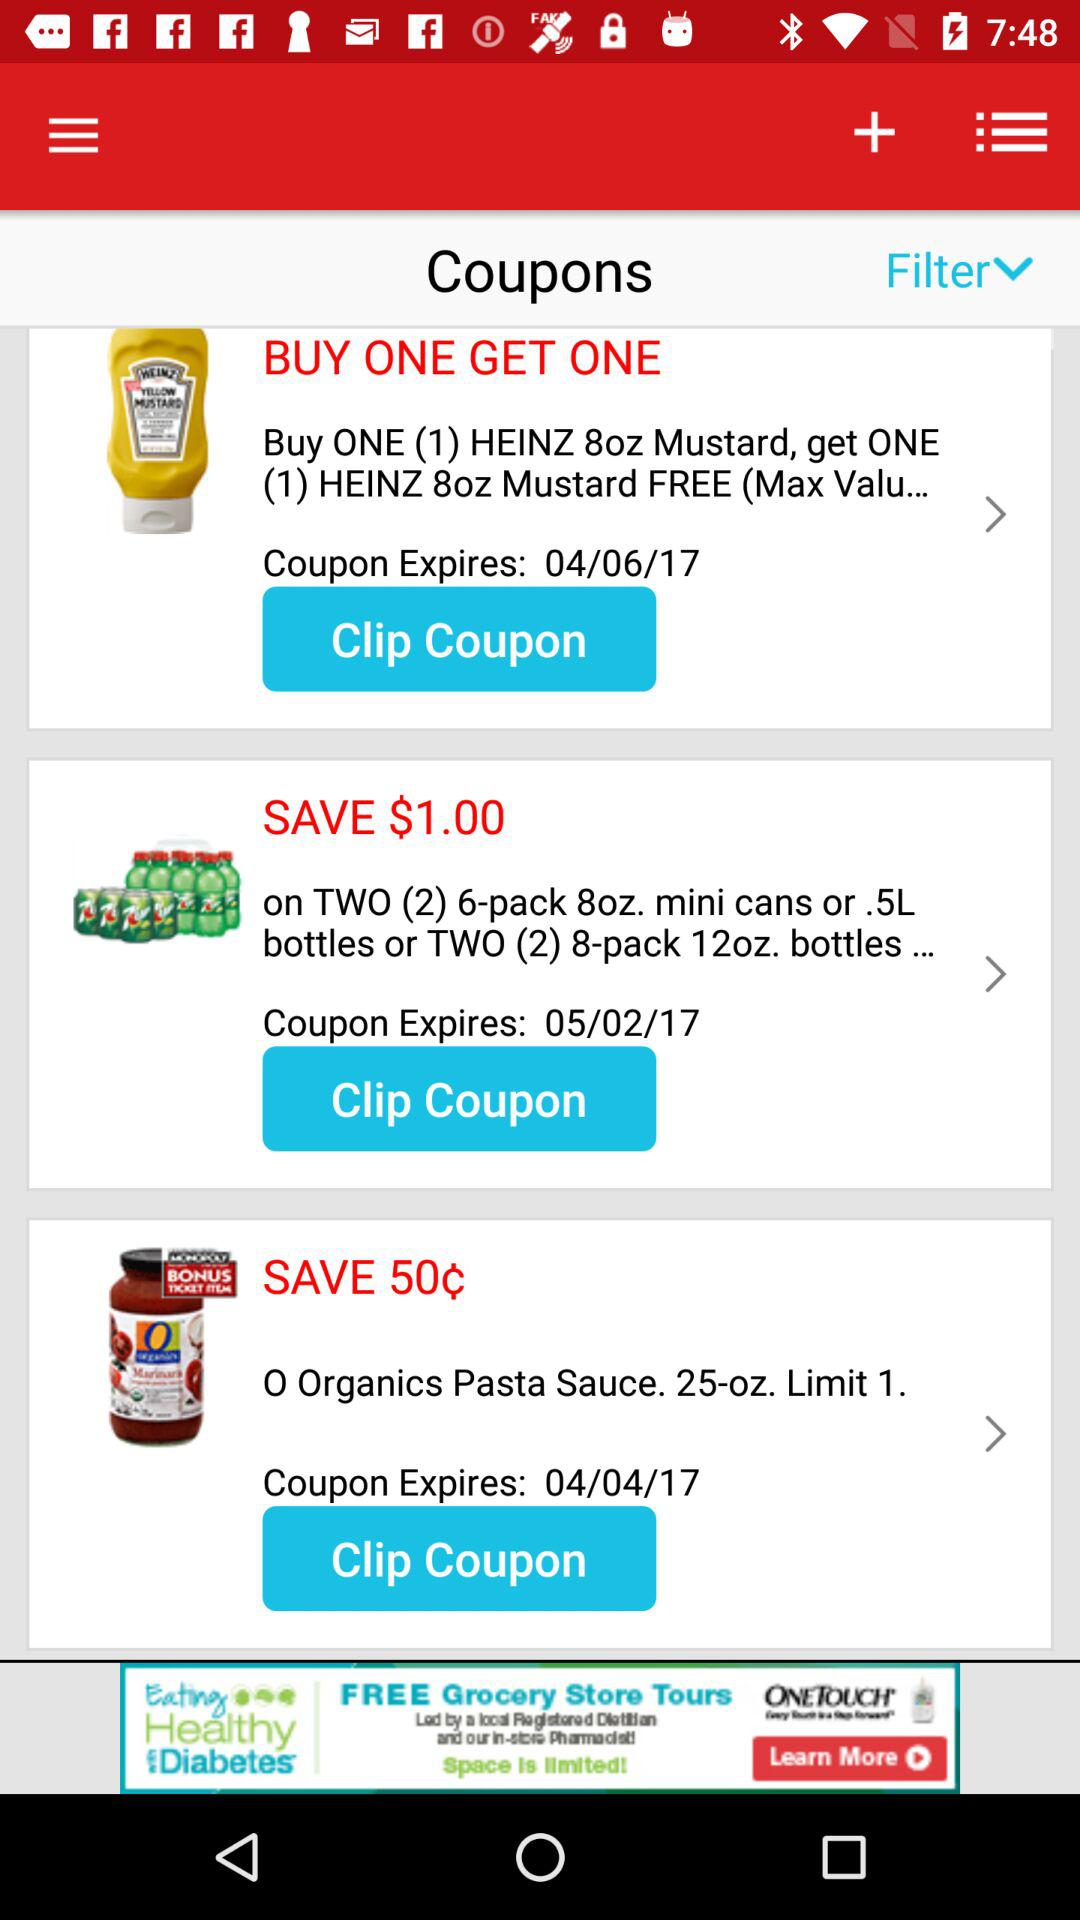How many coupons are expiring in April?
Answer the question using a single word or phrase. 2 